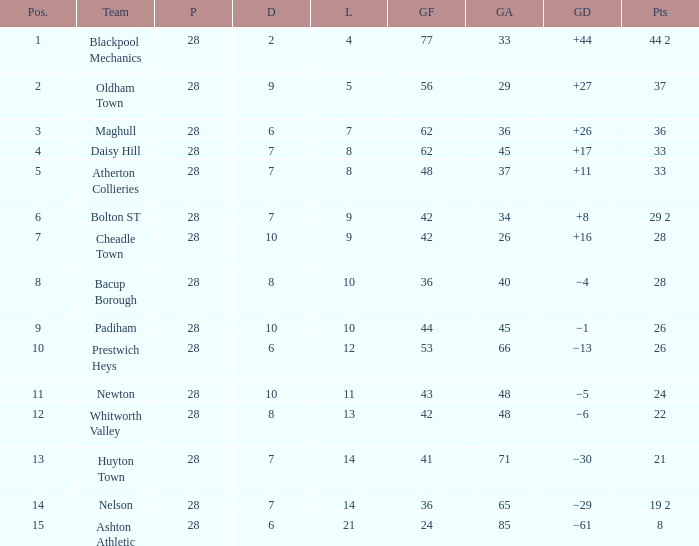What is the average played for entries with fewer than 65 goals against, points 1 of 19 2, and a position higher than 15? None. 